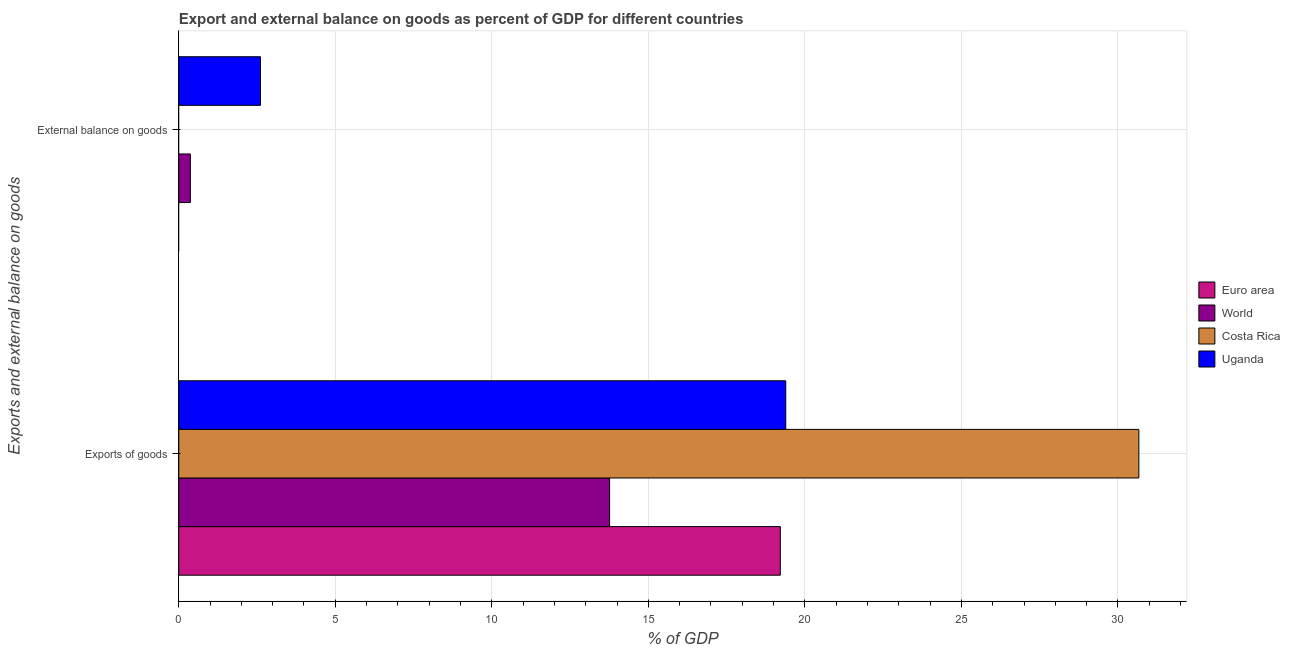How many bars are there on the 2nd tick from the top?
Provide a short and direct response. 4. How many bars are there on the 1st tick from the bottom?
Your answer should be compact. 4. What is the label of the 1st group of bars from the top?
Keep it short and to the point. External balance on goods. What is the external balance on goods as percentage of gdp in World?
Give a very brief answer. 0.37. Across all countries, what is the maximum external balance on goods as percentage of gdp?
Offer a terse response. 2.61. Across all countries, what is the minimum external balance on goods as percentage of gdp?
Keep it short and to the point. 0. In which country was the external balance on goods as percentage of gdp maximum?
Provide a succinct answer. Uganda. What is the total export of goods as percentage of gdp in the graph?
Give a very brief answer. 83.04. What is the difference between the export of goods as percentage of gdp in Euro area and that in Uganda?
Offer a very short reply. -0.17. What is the difference between the export of goods as percentage of gdp in Euro area and the external balance on goods as percentage of gdp in Costa Rica?
Your answer should be compact. 19.22. What is the average export of goods as percentage of gdp per country?
Provide a succinct answer. 20.76. What is the difference between the export of goods as percentage of gdp and external balance on goods as percentage of gdp in World?
Ensure brevity in your answer.  13.39. In how many countries, is the external balance on goods as percentage of gdp greater than 28 %?
Keep it short and to the point. 0. What is the ratio of the export of goods as percentage of gdp in Uganda to that in World?
Make the answer very short. 1.41. In how many countries, is the external balance on goods as percentage of gdp greater than the average external balance on goods as percentage of gdp taken over all countries?
Offer a very short reply. 1. Are all the bars in the graph horizontal?
Keep it short and to the point. Yes. How many countries are there in the graph?
Ensure brevity in your answer.  4. What is the difference between two consecutive major ticks on the X-axis?
Give a very brief answer. 5. Does the graph contain any zero values?
Give a very brief answer. Yes. Does the graph contain grids?
Your response must be concise. Yes. How are the legend labels stacked?
Your answer should be very brief. Vertical. What is the title of the graph?
Make the answer very short. Export and external balance on goods as percent of GDP for different countries. Does "Nigeria" appear as one of the legend labels in the graph?
Offer a very short reply. No. What is the label or title of the X-axis?
Your answer should be compact. % of GDP. What is the label or title of the Y-axis?
Provide a succinct answer. Exports and external balance on goods. What is the % of GDP in Euro area in Exports of goods?
Your answer should be compact. 19.22. What is the % of GDP of World in Exports of goods?
Give a very brief answer. 13.76. What is the % of GDP of Costa Rica in Exports of goods?
Your response must be concise. 30.67. What is the % of GDP in Uganda in Exports of goods?
Give a very brief answer. 19.39. What is the % of GDP of World in External balance on goods?
Make the answer very short. 0.37. What is the % of GDP in Costa Rica in External balance on goods?
Provide a short and direct response. 0. What is the % of GDP in Uganda in External balance on goods?
Provide a short and direct response. 2.61. Across all Exports and external balance on goods, what is the maximum % of GDP of Euro area?
Ensure brevity in your answer.  19.22. Across all Exports and external balance on goods, what is the maximum % of GDP of World?
Your response must be concise. 13.76. Across all Exports and external balance on goods, what is the maximum % of GDP of Costa Rica?
Provide a succinct answer. 30.67. Across all Exports and external balance on goods, what is the maximum % of GDP in Uganda?
Give a very brief answer. 19.39. Across all Exports and external balance on goods, what is the minimum % of GDP of World?
Give a very brief answer. 0.37. Across all Exports and external balance on goods, what is the minimum % of GDP of Uganda?
Your response must be concise. 2.61. What is the total % of GDP in Euro area in the graph?
Your response must be concise. 19.22. What is the total % of GDP in World in the graph?
Provide a short and direct response. 14.13. What is the total % of GDP in Costa Rica in the graph?
Make the answer very short. 30.67. What is the difference between the % of GDP in World in Exports of goods and that in External balance on goods?
Provide a succinct answer. 13.39. What is the difference between the % of GDP in Uganda in Exports of goods and that in External balance on goods?
Ensure brevity in your answer.  16.78. What is the difference between the % of GDP of Euro area in Exports of goods and the % of GDP of World in External balance on goods?
Ensure brevity in your answer.  18.84. What is the difference between the % of GDP in Euro area in Exports of goods and the % of GDP in Uganda in External balance on goods?
Keep it short and to the point. 16.61. What is the difference between the % of GDP in World in Exports of goods and the % of GDP in Uganda in External balance on goods?
Offer a terse response. 11.15. What is the difference between the % of GDP of Costa Rica in Exports of goods and the % of GDP of Uganda in External balance on goods?
Offer a very short reply. 28.06. What is the average % of GDP of Euro area per Exports and external balance on goods?
Offer a very short reply. 9.61. What is the average % of GDP in World per Exports and external balance on goods?
Your answer should be very brief. 7.07. What is the average % of GDP of Costa Rica per Exports and external balance on goods?
Your response must be concise. 15.33. What is the average % of GDP of Uganda per Exports and external balance on goods?
Provide a succinct answer. 11. What is the difference between the % of GDP of Euro area and % of GDP of World in Exports of goods?
Provide a short and direct response. 5.45. What is the difference between the % of GDP of Euro area and % of GDP of Costa Rica in Exports of goods?
Offer a terse response. -11.45. What is the difference between the % of GDP of Euro area and % of GDP of Uganda in Exports of goods?
Offer a very short reply. -0.17. What is the difference between the % of GDP of World and % of GDP of Costa Rica in Exports of goods?
Offer a terse response. -16.91. What is the difference between the % of GDP of World and % of GDP of Uganda in Exports of goods?
Your answer should be compact. -5.63. What is the difference between the % of GDP in Costa Rica and % of GDP in Uganda in Exports of goods?
Keep it short and to the point. 11.28. What is the difference between the % of GDP in World and % of GDP in Uganda in External balance on goods?
Provide a succinct answer. -2.24. What is the ratio of the % of GDP of World in Exports of goods to that in External balance on goods?
Offer a very short reply. 37.06. What is the ratio of the % of GDP of Uganda in Exports of goods to that in External balance on goods?
Your answer should be compact. 7.43. What is the difference between the highest and the second highest % of GDP of World?
Your response must be concise. 13.39. What is the difference between the highest and the second highest % of GDP of Uganda?
Make the answer very short. 16.78. What is the difference between the highest and the lowest % of GDP of Euro area?
Give a very brief answer. 19.22. What is the difference between the highest and the lowest % of GDP in World?
Your response must be concise. 13.39. What is the difference between the highest and the lowest % of GDP of Costa Rica?
Keep it short and to the point. 30.67. What is the difference between the highest and the lowest % of GDP of Uganda?
Provide a succinct answer. 16.78. 